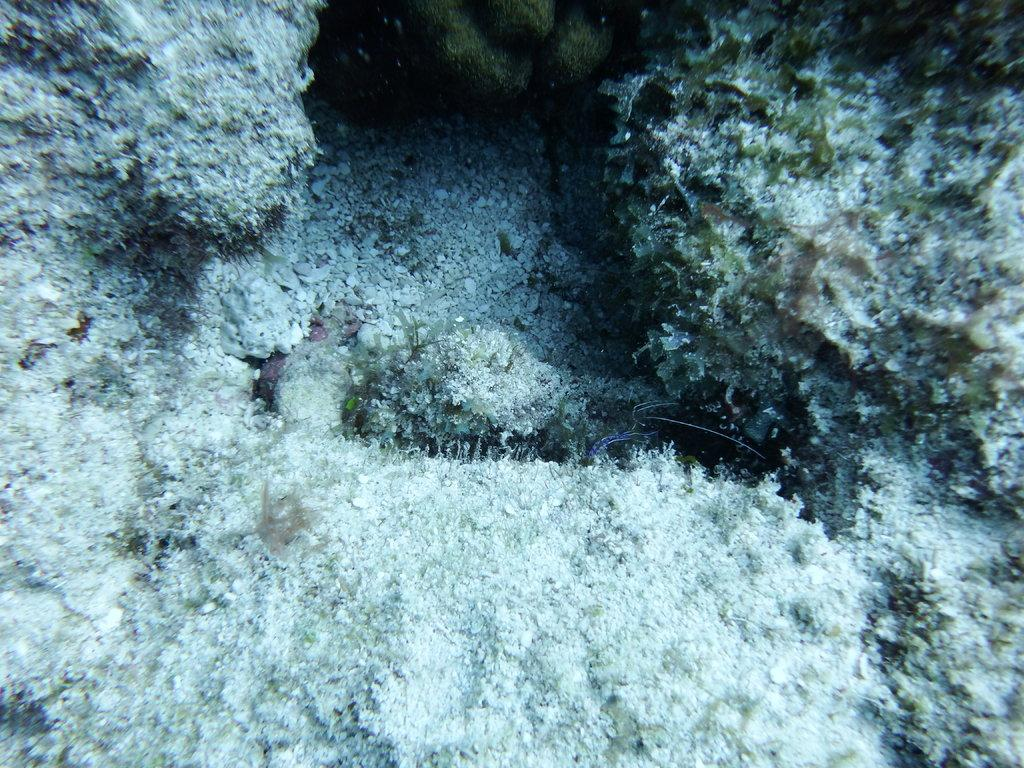What is the main subject of the image? The main subject of the image is a water body. Can you describe any specific features of the water body? Yes, there is algae present in the water. How much glue is needed to fix the dog in the image? There is no dog present in the image, so glue is not needed to fix anything. 